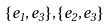<formula> <loc_0><loc_0><loc_500><loc_500>\{ e _ { 1 } , e _ { 3 } \} , \{ e _ { 2 } , e _ { 3 } \}</formula> 